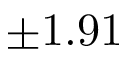Convert formula to latex. <formula><loc_0><loc_0><loc_500><loc_500>\pm 1 . 9 1</formula> 